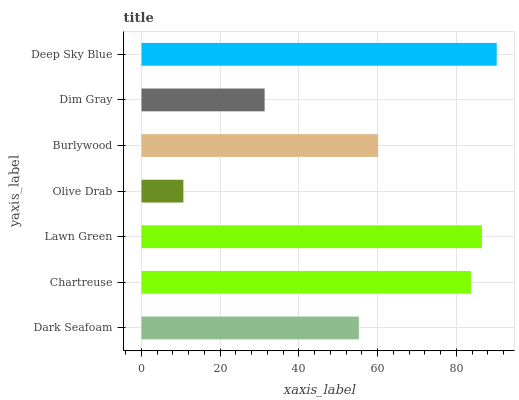Is Olive Drab the minimum?
Answer yes or no. Yes. Is Deep Sky Blue the maximum?
Answer yes or no. Yes. Is Chartreuse the minimum?
Answer yes or no. No. Is Chartreuse the maximum?
Answer yes or no. No. Is Chartreuse greater than Dark Seafoam?
Answer yes or no. Yes. Is Dark Seafoam less than Chartreuse?
Answer yes or no. Yes. Is Dark Seafoam greater than Chartreuse?
Answer yes or no. No. Is Chartreuse less than Dark Seafoam?
Answer yes or no. No. Is Burlywood the high median?
Answer yes or no. Yes. Is Burlywood the low median?
Answer yes or no. Yes. Is Dim Gray the high median?
Answer yes or no. No. Is Deep Sky Blue the low median?
Answer yes or no. No. 